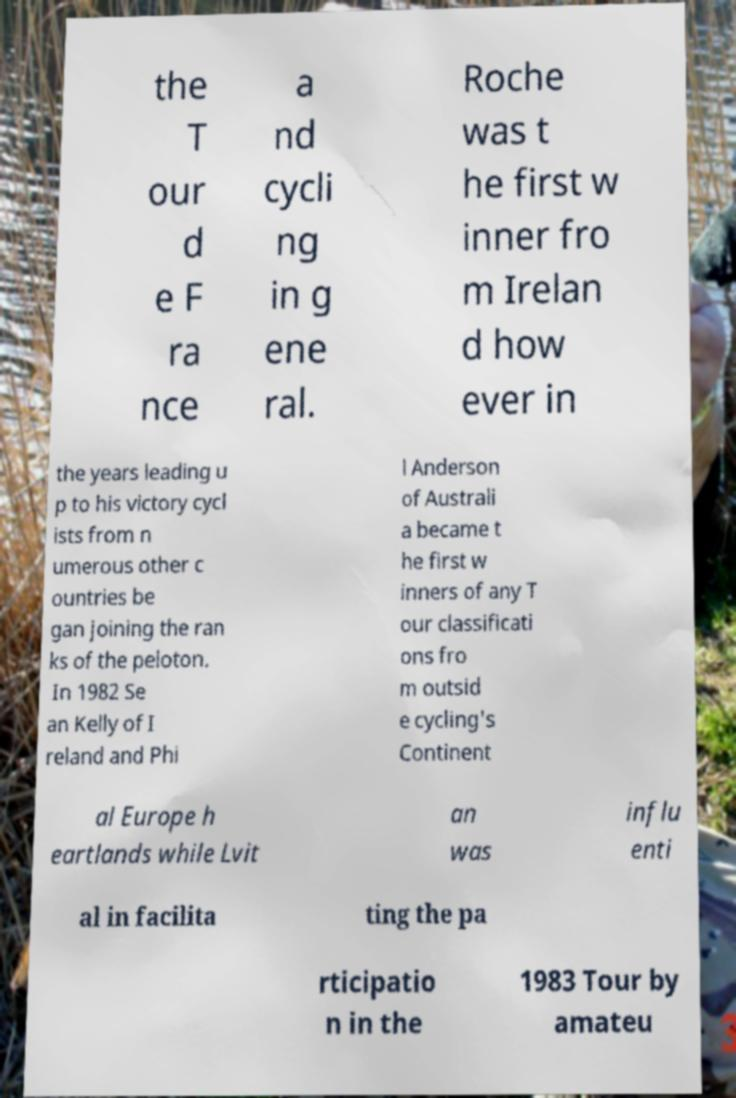What messages or text are displayed in this image? I need them in a readable, typed format. the T our d e F ra nce a nd cycli ng in g ene ral. Roche was t he first w inner fro m Irelan d how ever in the years leading u p to his victory cycl ists from n umerous other c ountries be gan joining the ran ks of the peloton. In 1982 Se an Kelly of I reland and Phi l Anderson of Australi a became t he first w inners of any T our classificati ons fro m outsid e cycling's Continent al Europe h eartlands while Lvit an was influ enti al in facilita ting the pa rticipatio n in the 1983 Tour by amateu 